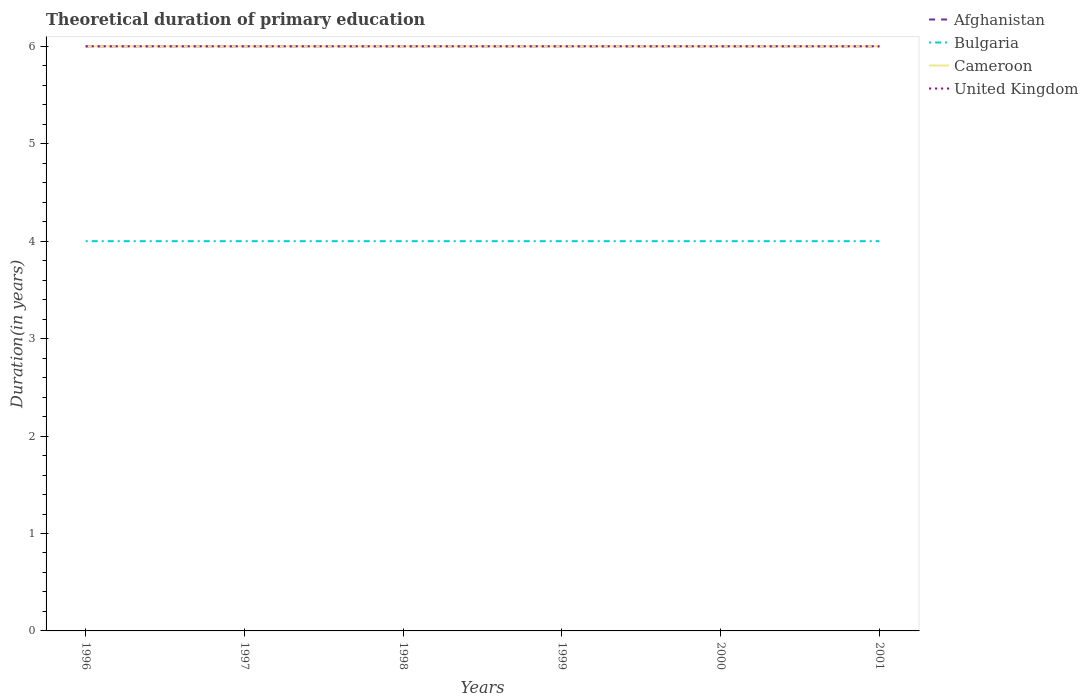Across all years, what is the maximum total theoretical duration of primary education in Bulgaria?
Provide a succinct answer. 4. In which year was the total theoretical duration of primary education in Afghanistan maximum?
Make the answer very short. 1996. What is the difference between the highest and the lowest total theoretical duration of primary education in Bulgaria?
Your response must be concise. 0. Is the total theoretical duration of primary education in United Kingdom strictly greater than the total theoretical duration of primary education in Afghanistan over the years?
Keep it short and to the point. No. How many lines are there?
Offer a terse response. 4. What is the difference between two consecutive major ticks on the Y-axis?
Provide a short and direct response. 1. Does the graph contain any zero values?
Provide a succinct answer. No. Does the graph contain grids?
Provide a short and direct response. No. Where does the legend appear in the graph?
Your answer should be very brief. Top right. How are the legend labels stacked?
Ensure brevity in your answer.  Vertical. What is the title of the graph?
Give a very brief answer. Theoretical duration of primary education. What is the label or title of the X-axis?
Make the answer very short. Years. What is the label or title of the Y-axis?
Your response must be concise. Duration(in years). What is the Duration(in years) of Bulgaria in 1996?
Provide a short and direct response. 4. What is the Duration(in years) in Cameroon in 1996?
Offer a terse response. 6. What is the Duration(in years) of Afghanistan in 1997?
Ensure brevity in your answer.  6. What is the Duration(in years) of Bulgaria in 1997?
Provide a succinct answer. 4. What is the Duration(in years) in Cameroon in 1997?
Provide a succinct answer. 6. What is the Duration(in years) of Afghanistan in 1998?
Provide a short and direct response. 6. What is the Duration(in years) in United Kingdom in 1998?
Ensure brevity in your answer.  6. What is the Duration(in years) in Cameroon in 1999?
Keep it short and to the point. 6. What is the Duration(in years) in United Kingdom in 1999?
Your response must be concise. 6. What is the Duration(in years) of Afghanistan in 2000?
Make the answer very short. 6. What is the Duration(in years) in Bulgaria in 2000?
Make the answer very short. 4. What is the Duration(in years) of Cameroon in 2000?
Make the answer very short. 6. What is the Duration(in years) in Afghanistan in 2001?
Offer a very short reply. 6. What is the Duration(in years) in Bulgaria in 2001?
Provide a succinct answer. 4. Across all years, what is the maximum Duration(in years) of Cameroon?
Give a very brief answer. 6. Across all years, what is the minimum Duration(in years) in Afghanistan?
Keep it short and to the point. 6. Across all years, what is the minimum Duration(in years) in Bulgaria?
Ensure brevity in your answer.  4. Across all years, what is the minimum Duration(in years) in United Kingdom?
Give a very brief answer. 6. What is the total Duration(in years) of Bulgaria in the graph?
Keep it short and to the point. 24. What is the total Duration(in years) of United Kingdom in the graph?
Make the answer very short. 36. What is the difference between the Duration(in years) of Afghanistan in 1996 and that in 1997?
Offer a terse response. 0. What is the difference between the Duration(in years) in Bulgaria in 1996 and that in 1997?
Provide a short and direct response. 0. What is the difference between the Duration(in years) of Cameroon in 1996 and that in 1997?
Your answer should be very brief. 0. What is the difference between the Duration(in years) of United Kingdom in 1996 and that in 1997?
Provide a succinct answer. 0. What is the difference between the Duration(in years) in Afghanistan in 1996 and that in 1998?
Offer a terse response. 0. What is the difference between the Duration(in years) of Bulgaria in 1996 and that in 1999?
Your answer should be compact. 0. What is the difference between the Duration(in years) in United Kingdom in 1996 and that in 1999?
Provide a short and direct response. 0. What is the difference between the Duration(in years) of Cameroon in 1996 and that in 2000?
Ensure brevity in your answer.  0. What is the difference between the Duration(in years) of United Kingdom in 1996 and that in 2000?
Make the answer very short. 0. What is the difference between the Duration(in years) in Bulgaria in 1997 and that in 1998?
Provide a short and direct response. 0. What is the difference between the Duration(in years) of United Kingdom in 1997 and that in 1998?
Offer a terse response. 0. What is the difference between the Duration(in years) in United Kingdom in 1997 and that in 1999?
Ensure brevity in your answer.  0. What is the difference between the Duration(in years) in Afghanistan in 1997 and that in 2000?
Your answer should be very brief. 0. What is the difference between the Duration(in years) of Cameroon in 1997 and that in 2000?
Provide a succinct answer. 0. What is the difference between the Duration(in years) of Afghanistan in 1997 and that in 2001?
Make the answer very short. 0. What is the difference between the Duration(in years) in United Kingdom in 1997 and that in 2001?
Make the answer very short. 0. What is the difference between the Duration(in years) in Afghanistan in 1998 and that in 1999?
Offer a terse response. 0. What is the difference between the Duration(in years) in Cameroon in 1998 and that in 1999?
Offer a very short reply. 0. What is the difference between the Duration(in years) of Afghanistan in 1998 and that in 2000?
Your answer should be compact. 0. What is the difference between the Duration(in years) in United Kingdom in 1998 and that in 2000?
Your answer should be compact. 0. What is the difference between the Duration(in years) of Afghanistan in 1998 and that in 2001?
Provide a succinct answer. 0. What is the difference between the Duration(in years) in Cameroon in 1998 and that in 2001?
Make the answer very short. 0. What is the difference between the Duration(in years) of United Kingdom in 1998 and that in 2001?
Keep it short and to the point. 0. What is the difference between the Duration(in years) of Afghanistan in 1999 and that in 2000?
Offer a terse response. 0. What is the difference between the Duration(in years) in Afghanistan in 1999 and that in 2001?
Your answer should be very brief. 0. What is the difference between the Duration(in years) of United Kingdom in 1999 and that in 2001?
Offer a terse response. 0. What is the difference between the Duration(in years) in Bulgaria in 2000 and that in 2001?
Your answer should be very brief. 0. What is the difference between the Duration(in years) of Cameroon in 2000 and that in 2001?
Your response must be concise. 0. What is the difference between the Duration(in years) in Afghanistan in 1996 and the Duration(in years) in Bulgaria in 1997?
Ensure brevity in your answer.  2. What is the difference between the Duration(in years) in Bulgaria in 1996 and the Duration(in years) in Cameroon in 1997?
Give a very brief answer. -2. What is the difference between the Duration(in years) of Afghanistan in 1996 and the Duration(in years) of Bulgaria in 1998?
Ensure brevity in your answer.  2. What is the difference between the Duration(in years) in Afghanistan in 1996 and the Duration(in years) in Cameroon in 1998?
Keep it short and to the point. 0. What is the difference between the Duration(in years) in Afghanistan in 1996 and the Duration(in years) in United Kingdom in 1998?
Ensure brevity in your answer.  0. What is the difference between the Duration(in years) of Bulgaria in 1996 and the Duration(in years) of Cameroon in 1998?
Offer a very short reply. -2. What is the difference between the Duration(in years) of Cameroon in 1996 and the Duration(in years) of United Kingdom in 1998?
Keep it short and to the point. 0. What is the difference between the Duration(in years) in Afghanistan in 1996 and the Duration(in years) in Cameroon in 1999?
Provide a succinct answer. 0. What is the difference between the Duration(in years) in Afghanistan in 1996 and the Duration(in years) in United Kingdom in 2000?
Ensure brevity in your answer.  0. What is the difference between the Duration(in years) of Bulgaria in 1996 and the Duration(in years) of United Kingdom in 2000?
Provide a succinct answer. -2. What is the difference between the Duration(in years) in Cameroon in 1996 and the Duration(in years) in United Kingdom in 2000?
Offer a terse response. 0. What is the difference between the Duration(in years) of Afghanistan in 1996 and the Duration(in years) of Bulgaria in 2001?
Your answer should be compact. 2. What is the difference between the Duration(in years) of Bulgaria in 1996 and the Duration(in years) of Cameroon in 2001?
Offer a terse response. -2. What is the difference between the Duration(in years) in Bulgaria in 1996 and the Duration(in years) in United Kingdom in 2001?
Make the answer very short. -2. What is the difference between the Duration(in years) of Afghanistan in 1997 and the Duration(in years) of Cameroon in 1998?
Make the answer very short. 0. What is the difference between the Duration(in years) in Afghanistan in 1997 and the Duration(in years) in United Kingdom in 1998?
Your answer should be compact. 0. What is the difference between the Duration(in years) of Cameroon in 1997 and the Duration(in years) of United Kingdom in 1999?
Give a very brief answer. 0. What is the difference between the Duration(in years) in Afghanistan in 1997 and the Duration(in years) in United Kingdom in 2000?
Keep it short and to the point. 0. What is the difference between the Duration(in years) of Afghanistan in 1997 and the Duration(in years) of Bulgaria in 2001?
Your response must be concise. 2. What is the difference between the Duration(in years) in Bulgaria in 1997 and the Duration(in years) in United Kingdom in 2001?
Your answer should be compact. -2. What is the difference between the Duration(in years) of Cameroon in 1997 and the Duration(in years) of United Kingdom in 2001?
Give a very brief answer. 0. What is the difference between the Duration(in years) in Afghanistan in 1998 and the Duration(in years) in Cameroon in 1999?
Offer a terse response. 0. What is the difference between the Duration(in years) in Afghanistan in 1998 and the Duration(in years) in United Kingdom in 1999?
Your response must be concise. 0. What is the difference between the Duration(in years) of Bulgaria in 1998 and the Duration(in years) of Cameroon in 1999?
Your response must be concise. -2. What is the difference between the Duration(in years) in Bulgaria in 1998 and the Duration(in years) in United Kingdom in 1999?
Offer a very short reply. -2. What is the difference between the Duration(in years) of Afghanistan in 1998 and the Duration(in years) of Bulgaria in 2000?
Ensure brevity in your answer.  2. What is the difference between the Duration(in years) of Afghanistan in 1998 and the Duration(in years) of Cameroon in 2000?
Make the answer very short. 0. What is the difference between the Duration(in years) of Afghanistan in 1998 and the Duration(in years) of United Kingdom in 2000?
Your answer should be compact. 0. What is the difference between the Duration(in years) in Bulgaria in 1998 and the Duration(in years) in Cameroon in 2000?
Offer a very short reply. -2. What is the difference between the Duration(in years) in Cameroon in 1998 and the Duration(in years) in United Kingdom in 2000?
Ensure brevity in your answer.  0. What is the difference between the Duration(in years) in Afghanistan in 1998 and the Duration(in years) in United Kingdom in 2001?
Offer a terse response. 0. What is the difference between the Duration(in years) of Cameroon in 1998 and the Duration(in years) of United Kingdom in 2001?
Your response must be concise. 0. What is the difference between the Duration(in years) in Afghanistan in 1999 and the Duration(in years) in Cameroon in 2000?
Your answer should be very brief. 0. What is the difference between the Duration(in years) of Afghanistan in 1999 and the Duration(in years) of United Kingdom in 2000?
Make the answer very short. 0. What is the difference between the Duration(in years) in Bulgaria in 1999 and the Duration(in years) in Cameroon in 2000?
Ensure brevity in your answer.  -2. What is the difference between the Duration(in years) of Bulgaria in 1999 and the Duration(in years) of United Kingdom in 2000?
Your answer should be compact. -2. What is the difference between the Duration(in years) of Afghanistan in 1999 and the Duration(in years) of Bulgaria in 2001?
Keep it short and to the point. 2. What is the difference between the Duration(in years) in Afghanistan in 1999 and the Duration(in years) in United Kingdom in 2001?
Give a very brief answer. 0. What is the difference between the Duration(in years) in Bulgaria in 1999 and the Duration(in years) in Cameroon in 2001?
Your answer should be very brief. -2. What is the difference between the Duration(in years) in Afghanistan in 2000 and the Duration(in years) in Cameroon in 2001?
Offer a very short reply. 0. What is the difference between the Duration(in years) in Bulgaria in 2000 and the Duration(in years) in United Kingdom in 2001?
Your answer should be compact. -2. What is the average Duration(in years) of Cameroon per year?
Offer a terse response. 6. In the year 1996, what is the difference between the Duration(in years) of Afghanistan and Duration(in years) of Cameroon?
Make the answer very short. 0. In the year 1996, what is the difference between the Duration(in years) in Afghanistan and Duration(in years) in United Kingdom?
Ensure brevity in your answer.  0. In the year 1997, what is the difference between the Duration(in years) in Afghanistan and Duration(in years) in Bulgaria?
Offer a terse response. 2. In the year 1997, what is the difference between the Duration(in years) in Bulgaria and Duration(in years) in United Kingdom?
Offer a very short reply. -2. In the year 1998, what is the difference between the Duration(in years) in Afghanistan and Duration(in years) in Bulgaria?
Make the answer very short. 2. In the year 1998, what is the difference between the Duration(in years) in Afghanistan and Duration(in years) in Cameroon?
Make the answer very short. 0. In the year 1998, what is the difference between the Duration(in years) in Afghanistan and Duration(in years) in United Kingdom?
Ensure brevity in your answer.  0. In the year 1999, what is the difference between the Duration(in years) of Bulgaria and Duration(in years) of United Kingdom?
Ensure brevity in your answer.  -2. In the year 2000, what is the difference between the Duration(in years) in Afghanistan and Duration(in years) in Bulgaria?
Your response must be concise. 2. In the year 2000, what is the difference between the Duration(in years) of Bulgaria and Duration(in years) of Cameroon?
Keep it short and to the point. -2. In the year 2001, what is the difference between the Duration(in years) of Afghanistan and Duration(in years) of Bulgaria?
Your response must be concise. 2. In the year 2001, what is the difference between the Duration(in years) of Afghanistan and Duration(in years) of United Kingdom?
Your answer should be very brief. 0. In the year 2001, what is the difference between the Duration(in years) of Bulgaria and Duration(in years) of Cameroon?
Provide a succinct answer. -2. In the year 2001, what is the difference between the Duration(in years) of Bulgaria and Duration(in years) of United Kingdom?
Make the answer very short. -2. In the year 2001, what is the difference between the Duration(in years) in Cameroon and Duration(in years) in United Kingdom?
Your answer should be compact. 0. What is the ratio of the Duration(in years) in Cameroon in 1996 to that in 1997?
Ensure brevity in your answer.  1. What is the ratio of the Duration(in years) of United Kingdom in 1996 to that in 1997?
Keep it short and to the point. 1. What is the ratio of the Duration(in years) in Afghanistan in 1996 to that in 1998?
Your answer should be very brief. 1. What is the ratio of the Duration(in years) in Cameroon in 1996 to that in 1998?
Keep it short and to the point. 1. What is the ratio of the Duration(in years) of United Kingdom in 1996 to that in 1998?
Give a very brief answer. 1. What is the ratio of the Duration(in years) in Bulgaria in 1996 to that in 1999?
Provide a succinct answer. 1. What is the ratio of the Duration(in years) of Bulgaria in 1996 to that in 2000?
Provide a short and direct response. 1. What is the ratio of the Duration(in years) in United Kingdom in 1996 to that in 2000?
Offer a terse response. 1. What is the ratio of the Duration(in years) of Afghanistan in 1996 to that in 2001?
Give a very brief answer. 1. What is the ratio of the Duration(in years) of Bulgaria in 1996 to that in 2001?
Your answer should be very brief. 1. What is the ratio of the Duration(in years) in Cameroon in 1996 to that in 2001?
Your answer should be compact. 1. What is the ratio of the Duration(in years) of United Kingdom in 1996 to that in 2001?
Offer a terse response. 1. What is the ratio of the Duration(in years) of Afghanistan in 1997 to that in 1998?
Provide a succinct answer. 1. What is the ratio of the Duration(in years) in United Kingdom in 1997 to that in 1999?
Keep it short and to the point. 1. What is the ratio of the Duration(in years) in Afghanistan in 1997 to that in 2000?
Provide a succinct answer. 1. What is the ratio of the Duration(in years) in United Kingdom in 1997 to that in 2000?
Offer a terse response. 1. What is the ratio of the Duration(in years) in Afghanistan in 1997 to that in 2001?
Offer a very short reply. 1. What is the ratio of the Duration(in years) in Cameroon in 1997 to that in 2001?
Your answer should be compact. 1. What is the ratio of the Duration(in years) of United Kingdom in 1997 to that in 2001?
Your answer should be very brief. 1. What is the ratio of the Duration(in years) in Afghanistan in 1998 to that in 1999?
Offer a terse response. 1. What is the ratio of the Duration(in years) in Afghanistan in 1998 to that in 2000?
Your response must be concise. 1. What is the ratio of the Duration(in years) in Bulgaria in 1998 to that in 2000?
Offer a very short reply. 1. What is the ratio of the Duration(in years) in Cameroon in 1998 to that in 2000?
Offer a terse response. 1. What is the ratio of the Duration(in years) of Bulgaria in 1998 to that in 2001?
Make the answer very short. 1. What is the ratio of the Duration(in years) in Cameroon in 1998 to that in 2001?
Your answer should be very brief. 1. What is the ratio of the Duration(in years) in Afghanistan in 1999 to that in 2000?
Keep it short and to the point. 1. What is the ratio of the Duration(in years) of Bulgaria in 1999 to that in 2000?
Provide a short and direct response. 1. What is the ratio of the Duration(in years) of Cameroon in 1999 to that in 2000?
Provide a short and direct response. 1. What is the ratio of the Duration(in years) in Cameroon in 1999 to that in 2001?
Provide a short and direct response. 1. What is the ratio of the Duration(in years) in Cameroon in 2000 to that in 2001?
Ensure brevity in your answer.  1. What is the ratio of the Duration(in years) in United Kingdom in 2000 to that in 2001?
Offer a terse response. 1. What is the difference between the highest and the second highest Duration(in years) of Afghanistan?
Offer a very short reply. 0. What is the difference between the highest and the second highest Duration(in years) of Bulgaria?
Offer a terse response. 0. What is the difference between the highest and the second highest Duration(in years) in Cameroon?
Your response must be concise. 0. What is the difference between the highest and the lowest Duration(in years) of Afghanistan?
Provide a succinct answer. 0. What is the difference between the highest and the lowest Duration(in years) of Bulgaria?
Your response must be concise. 0. What is the difference between the highest and the lowest Duration(in years) of Cameroon?
Offer a very short reply. 0. 